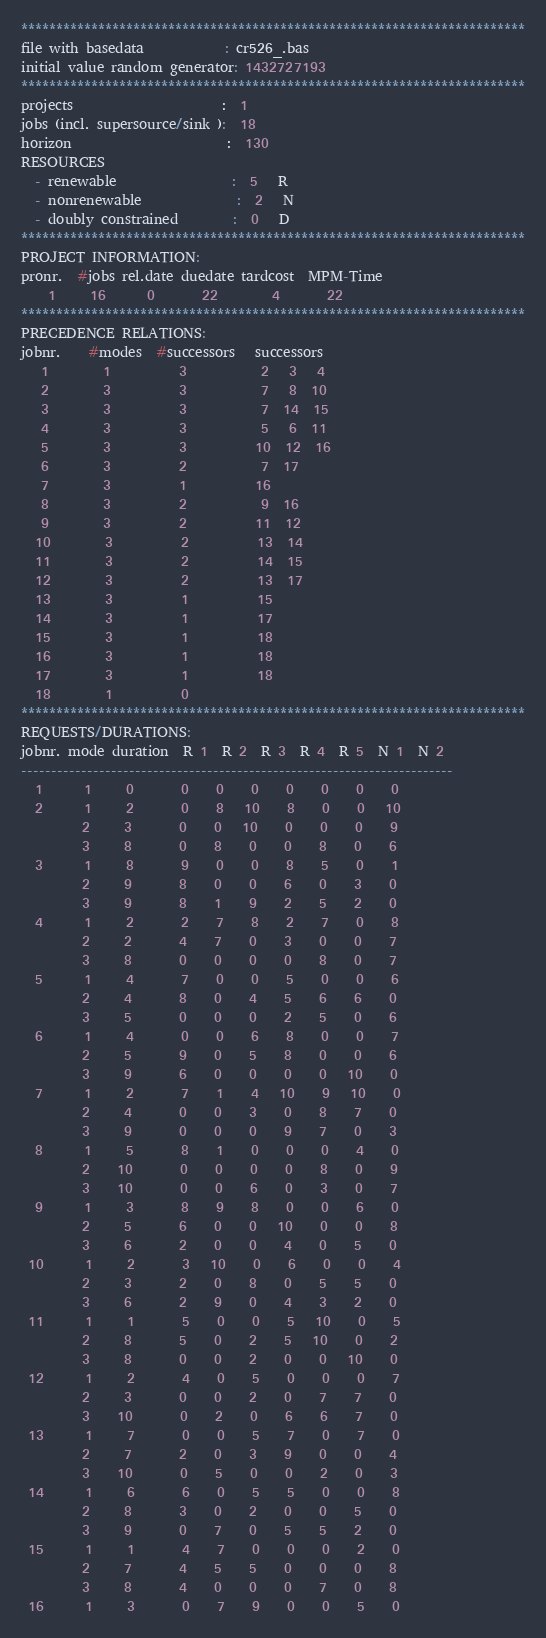Convert code to text. <code><loc_0><loc_0><loc_500><loc_500><_ObjectiveC_>************************************************************************
file with basedata            : cr526_.bas
initial value random generator: 1432727193
************************************************************************
projects                      :  1
jobs (incl. supersource/sink ):  18
horizon                       :  130
RESOURCES
  - renewable                 :  5   R
  - nonrenewable              :  2   N
  - doubly constrained        :  0   D
************************************************************************
PROJECT INFORMATION:
pronr.  #jobs rel.date duedate tardcost  MPM-Time
    1     16      0       22        4       22
************************************************************************
PRECEDENCE RELATIONS:
jobnr.    #modes  #successors   successors
   1        1          3           2   3   4
   2        3          3           7   8  10
   3        3          3           7  14  15
   4        3          3           5   6  11
   5        3          3          10  12  16
   6        3          2           7  17
   7        3          1          16
   8        3          2           9  16
   9        3          2          11  12
  10        3          2          13  14
  11        3          2          14  15
  12        3          2          13  17
  13        3          1          15
  14        3          1          17
  15        3          1          18
  16        3          1          18
  17        3          1          18
  18        1          0        
************************************************************************
REQUESTS/DURATIONS:
jobnr. mode duration  R 1  R 2  R 3  R 4  R 5  N 1  N 2
------------------------------------------------------------------------
  1      1     0       0    0    0    0    0    0    0
  2      1     2       0    8   10    8    0    0   10
         2     3       0    0   10    0    0    0    9
         3     8       0    8    0    0    8    0    6
  3      1     8       9    0    0    8    5    0    1
         2     9       8    0    0    6    0    3    0
         3     9       8    1    9    2    5    2    0
  4      1     2       2    7    8    2    7    0    8
         2     2       4    7    0    3    0    0    7
         3     8       0    0    0    0    8    0    7
  5      1     4       7    0    0    5    0    0    6
         2     4       8    0    4    5    6    6    0
         3     5       0    0    0    2    5    0    6
  6      1     4       0    0    6    8    0    0    7
         2     5       9    0    5    8    0    0    6
         3     9       6    0    0    0    0   10    0
  7      1     2       7    1    4   10    9   10    0
         2     4       0    0    3    0    8    7    0
         3     9       0    0    0    9    7    0    3
  8      1     5       8    1    0    0    0    4    0
         2    10       0    0    0    0    8    0    9
         3    10       0    0    6    0    3    0    7
  9      1     3       8    9    8    0    0    6    0
         2     5       6    0    0   10    0    0    8
         3     6       2    0    0    4    0    5    0
 10      1     2       3   10    0    6    0    0    4
         2     3       2    0    8    0    5    5    0
         3     6       2    9    0    4    3    2    0
 11      1     1       5    0    0    5   10    0    5
         2     8       5    0    2    5   10    0    2
         3     8       0    0    2    0    0   10    0
 12      1     2       4    0    5    0    0    0    7
         2     3       0    0    2    0    7    7    0
         3    10       0    2    0    6    6    7    0
 13      1     7       0    0    5    7    0    7    0
         2     7       2    0    3    9    0    0    4
         3    10       0    5    0    0    2    0    3
 14      1     6       6    0    5    5    0    0    8
         2     8       3    0    2    0    0    5    0
         3     9       0    7    0    5    5    2    0
 15      1     1       4    7    0    0    0    2    0
         2     7       4    5    5    0    0    0    8
         3     8       4    0    0    0    7    0    8
 16      1     3       0    7    9    0    0    5    0</code> 